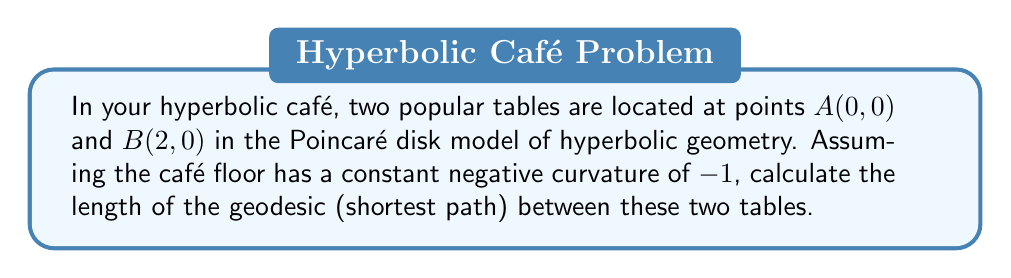Provide a solution to this math problem. To solve this problem, we'll follow these steps:

1) In the Poincaré disk model, the geodesic between two points on the x-axis is an arc of a circle that intersects the unit circle at right angles.

2) For points A(0, 0) and B(2, 0), this arc is part of a circle centered on the x-axis.

3) The hyperbolic distance $d$ between two points $(x_1, y_1)$ and $(x_2, y_2)$ in the Poincaré disk model is given by:

   $$d = \text{arcosh}\left(1 + \frac{2(x_2-x_1)^2 + 2(y_2-y_1)^2}{(1-x_1^2-y_1^2)(1-x_2^2-y_2^2)}\right)$$

4) Substituting our points A(0, 0) and B(2, 0):

   $$d = \text{arcosh}\left(1 + \frac{2(2-0)^2 + 2(0-0)^2}{(1-0^2-0^2)(1-2^2-0^2)}\right)$$

5) Simplifying:

   $$d = \text{arcosh}\left(1 + \frac{8}{1 \cdot (-3)}\right) = \text{arcosh}\left(1 - \frac{8}{3}\right)$$

6) Further simplification:

   $$d = \text{arcosh}\left(-\frac{5}{3}\right)$$

7) The arccosh function is defined for values ≥ 1, but our argument is negative. This indicates that the points are not within the Poincaré disk model (as B(2, 0) is outside the unit circle).

8) To correct this, we need to scale our coordinates to fit within the unit disk. Let's scale by a factor of 1/3:

   New coordinates: A(0, 0) and B(2/3, 0)

9) Recalculating with these new coordinates:

   $$d = \text{arcosh}\left(1 + \frac{2(2/3-0)^2 + 2(0-0)^2}{(1-0^2-0^2)(1-(2/3)^2-0^2)}\right)$$

10) Simplifying:

    $$d = \text{arcosh}\left(1 + \frac{8/9}{1 \cdot (1-4/9)}\right) = \text{arcosh}\left(1 + \frac{8/9}{5/9}\right) = \text{arcosh}\left(\frac{13}{5}\right)$$

Therefore, the length of the geodesic between the two tables is $\text{arcosh}\left(\frac{13}{5}\right)$.

[asy]
import geometry;

unitcircle();
dot((0,0));
dot((2/3,0));
draw(Arc((0,0), (2/3,0), 180), blue);
label("A", (0,0), SW);
label("B", (2/3,0), SE);
[/asy]
Answer: $\text{arcosh}\left(\frac{13}{5}\right)$ 